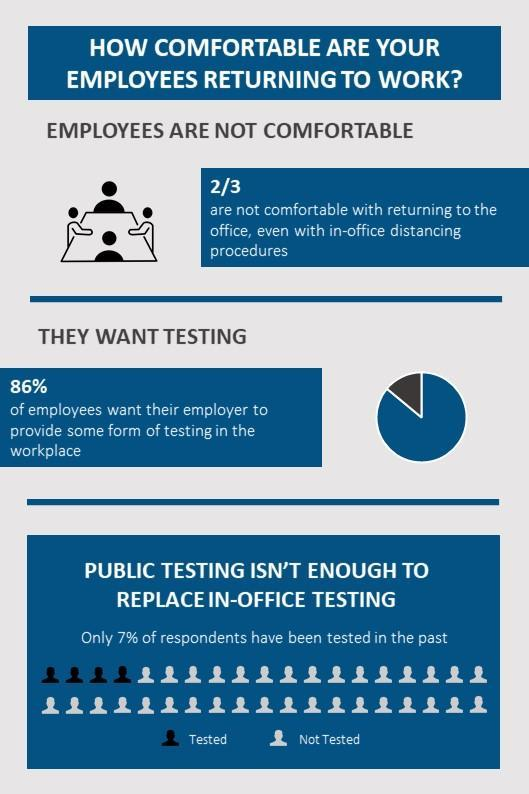What do nearly 7/8 of the employees want to be provided?
Answer the question with a short phrase. some form of testing in the workplace How many of the employees are comfortable with returning to work? 1/3 